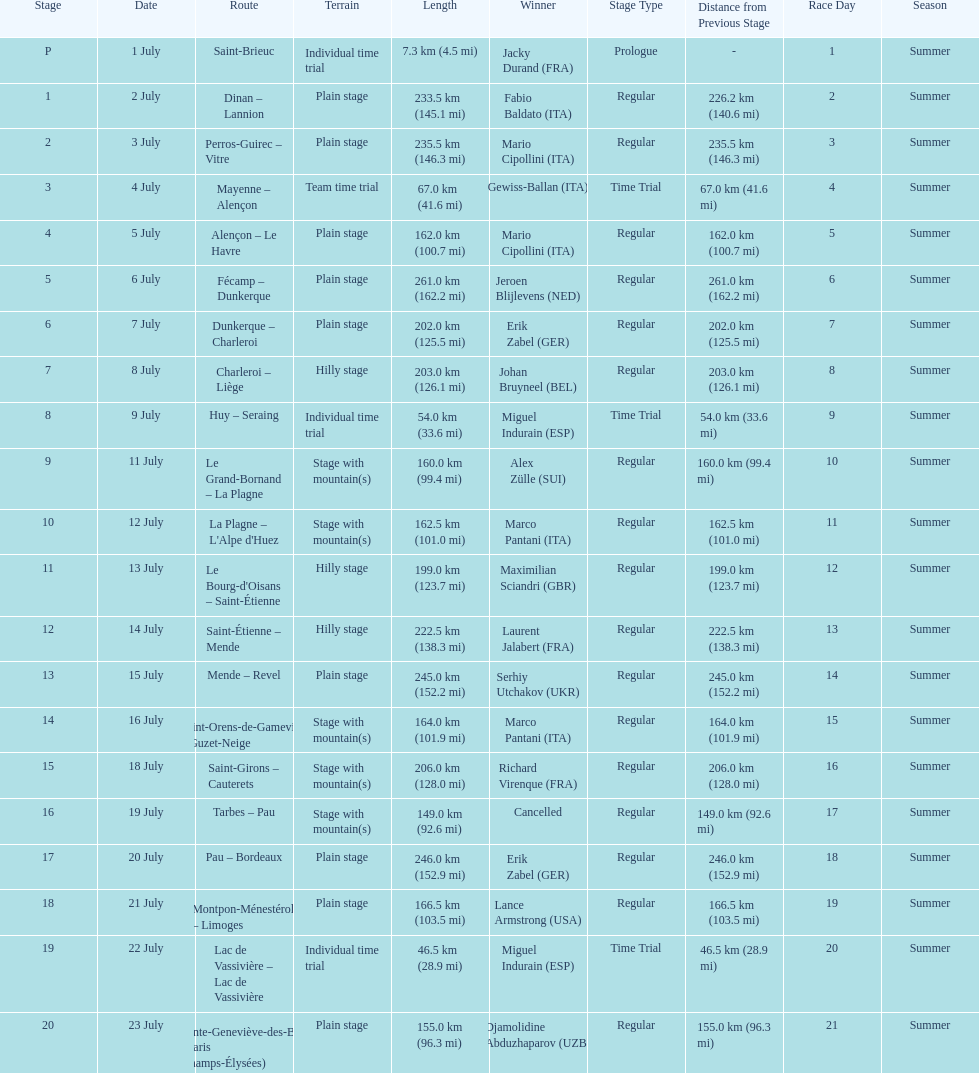How much longer is the 20th tour de france stage than the 19th? 108.5 km. 